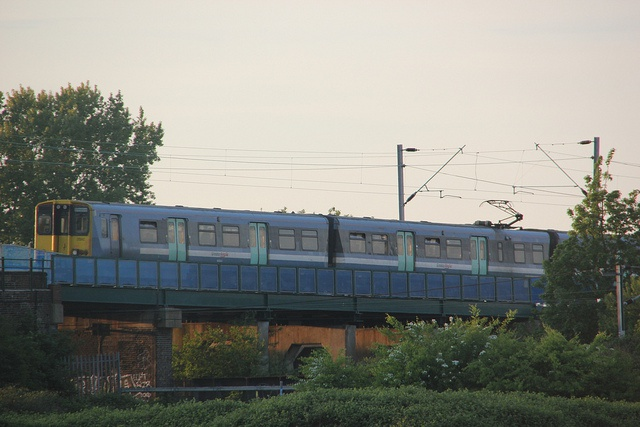Describe the objects in this image and their specific colors. I can see a train in lightgray, gray, blue, and black tones in this image. 